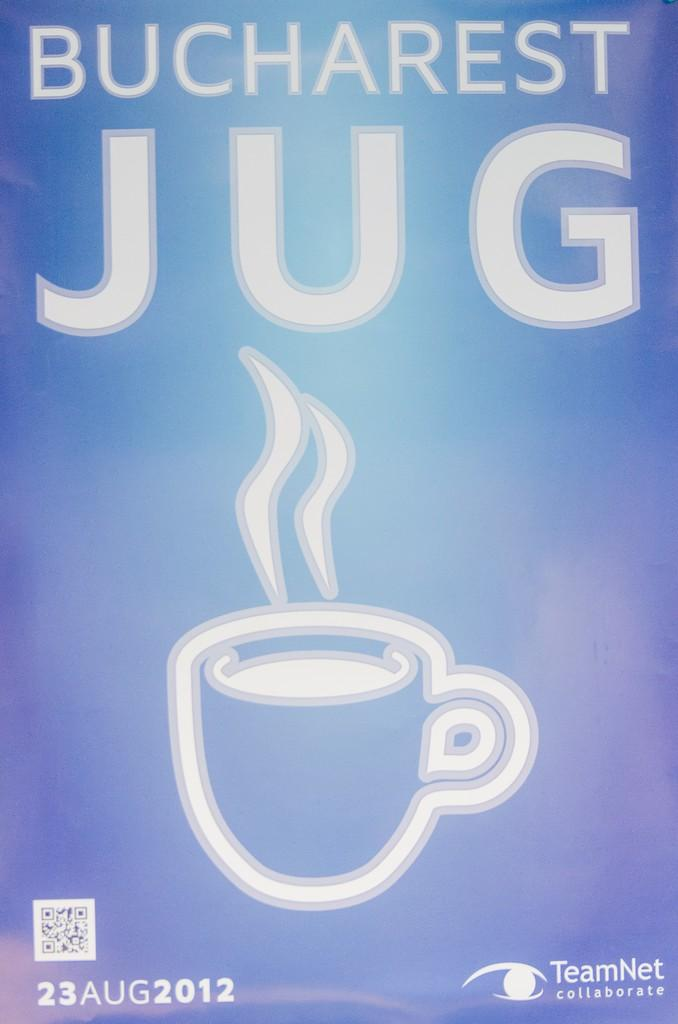What type of document is shown in the image? The image is a pamphlet of a company. What can be found inside the pamphlet? The pamphlet contains an image of a cup. What type of pipe is visible in the image? There is no pipe present in the image; it is a company pamphlet with an image of a cup. What can be seen in the aftermath of the event depicted in the image? There is no event depicted in the image, as it is a company pamphlet with an image of a cup. 